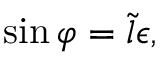<formula> <loc_0><loc_0><loc_500><loc_500>\sin \varphi = \tilde { l } \epsilon ,</formula> 